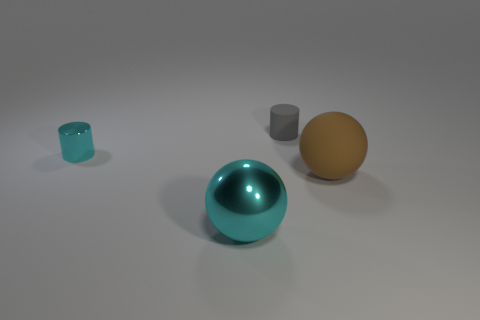Is the number of big metal spheres that are to the left of the large metal thing the same as the number of small objects behind the big matte object?
Provide a succinct answer. No. Does the small gray object have the same shape as the thing on the left side of the shiny sphere?
Your answer should be compact. Yes. There is a big object that is the same color as the metallic cylinder; what is its material?
Ensure brevity in your answer.  Metal. Do the large cyan ball and the tiny cylinder right of the tiny cyan object have the same material?
Offer a very short reply. No. There is a cylinder to the right of the cyan metal thing that is in front of the tiny object that is in front of the small rubber cylinder; what is its color?
Offer a terse response. Gray. There is a large metal sphere; is its color the same as the shiny thing that is left of the shiny ball?
Make the answer very short. Yes. The big shiny sphere has what color?
Give a very brief answer. Cyan. What is the shape of the large object that is to the left of the small gray rubber thing to the right of the sphere that is in front of the brown object?
Offer a very short reply. Sphere. How many other things are the same color as the rubber ball?
Provide a succinct answer. 0. Are there more large spheres behind the tiny gray cylinder than tiny cylinders right of the tiny metal cylinder?
Offer a terse response. No. 